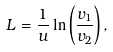Convert formula to latex. <formula><loc_0><loc_0><loc_500><loc_500>L = \frac { 1 } { u } \ln \left ( \frac { v _ { 1 } } { v _ { 2 } } \right ) ,</formula> 